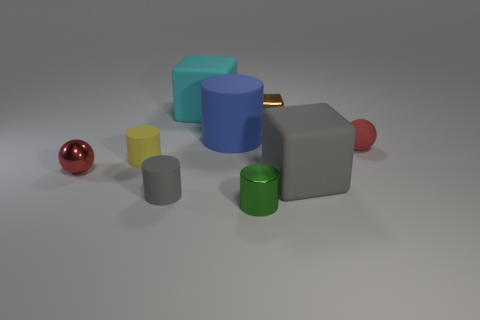Add 1 purple rubber balls. How many objects exist? 10 Subtract all blocks. How many objects are left? 6 Add 5 blue objects. How many blue objects are left? 6 Add 5 big metal cubes. How many big metal cubes exist? 5 Subtract 0 red blocks. How many objects are left? 9 Subtract all small brown balls. Subtract all matte balls. How many objects are left? 8 